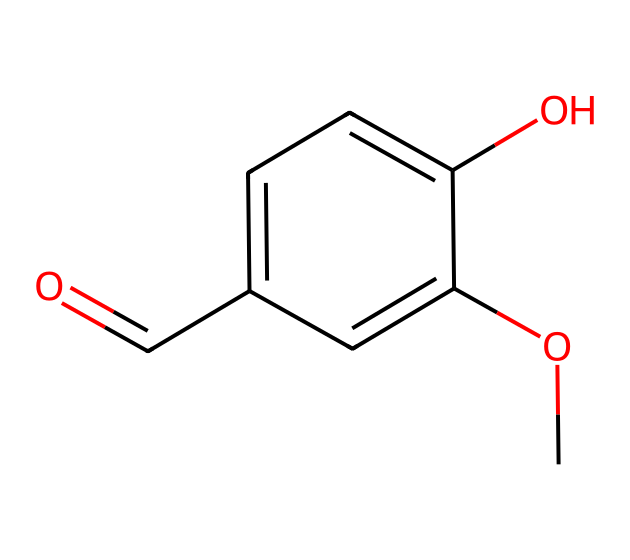What is the main functional group in vanillin? The structure contains a carbonyl group (C=O), characteristic of aldehydes, and this is the main functional group.
Answer: aldehyde How many hydroxyl groups are present in the chemical structure? The structure contains one hydroxyl group (-OH) attached to the aromatic ring, indicated by the 'O' in the position notation.
Answer: one What is the total number of carbon atoms in vanillin? By counting the carbon atoms in the SMILES representation, we find there are eight carbon atoms.
Answer: eight Which part of the molecule contributes to its flavor profile? The methoxy group (-OCH3) and the hydroxyl group (-OH) attached to the aromatic ring enhance vanillin's flavor profile by adding sweetness and creaminess to its taste.
Answer: methoxy group Is vanillin a saturated or unsaturated compound? The presence of a double bond in the carbonyl group (C=O) indicates that vanillin is an unsaturated compound.
Answer: unsaturated What type of isomerism can vanillin exhibit? Vanillin can exhibit structural isomerism due to variations in the positioning of the functional groups while maintaining the same molecular formula.
Answer: structural isomerism Does the structural formula of vanillin indicate it can participate in hydrogen bonding? The presence of the hydroxyl functional group (-OH) suggests that vanillin can participate in hydrogen bonding with other polar molecules.
Answer: yes 